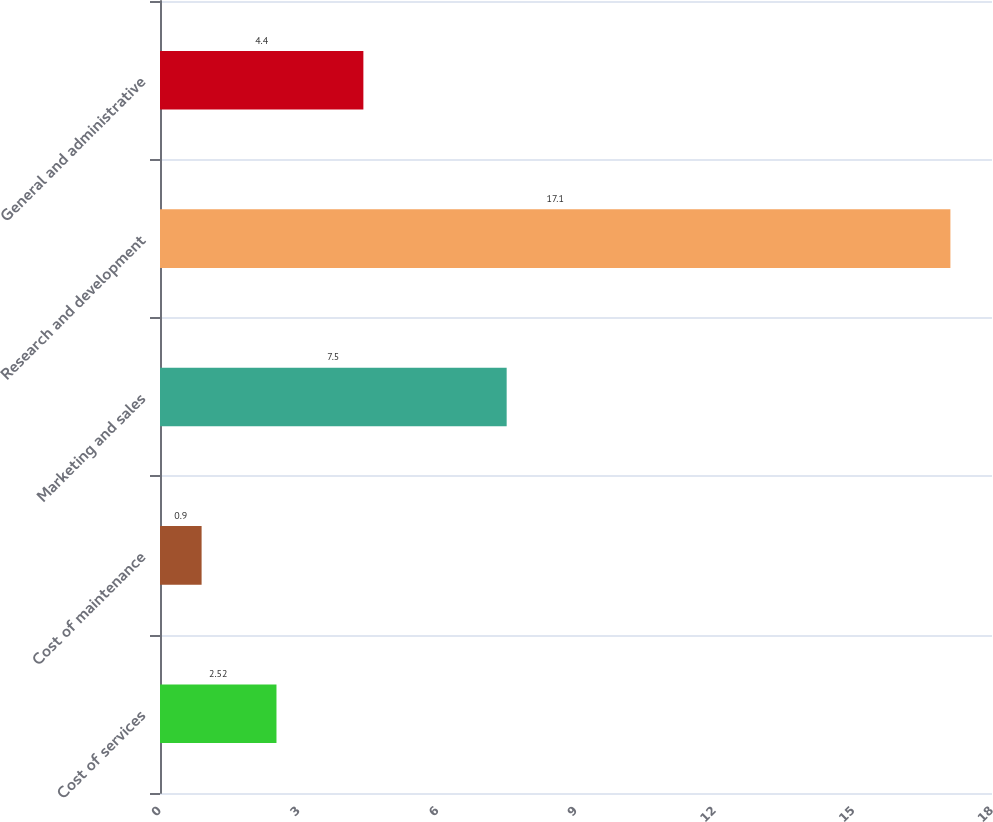<chart> <loc_0><loc_0><loc_500><loc_500><bar_chart><fcel>Cost of services<fcel>Cost of maintenance<fcel>Marketing and sales<fcel>Research and development<fcel>General and administrative<nl><fcel>2.52<fcel>0.9<fcel>7.5<fcel>17.1<fcel>4.4<nl></chart> 